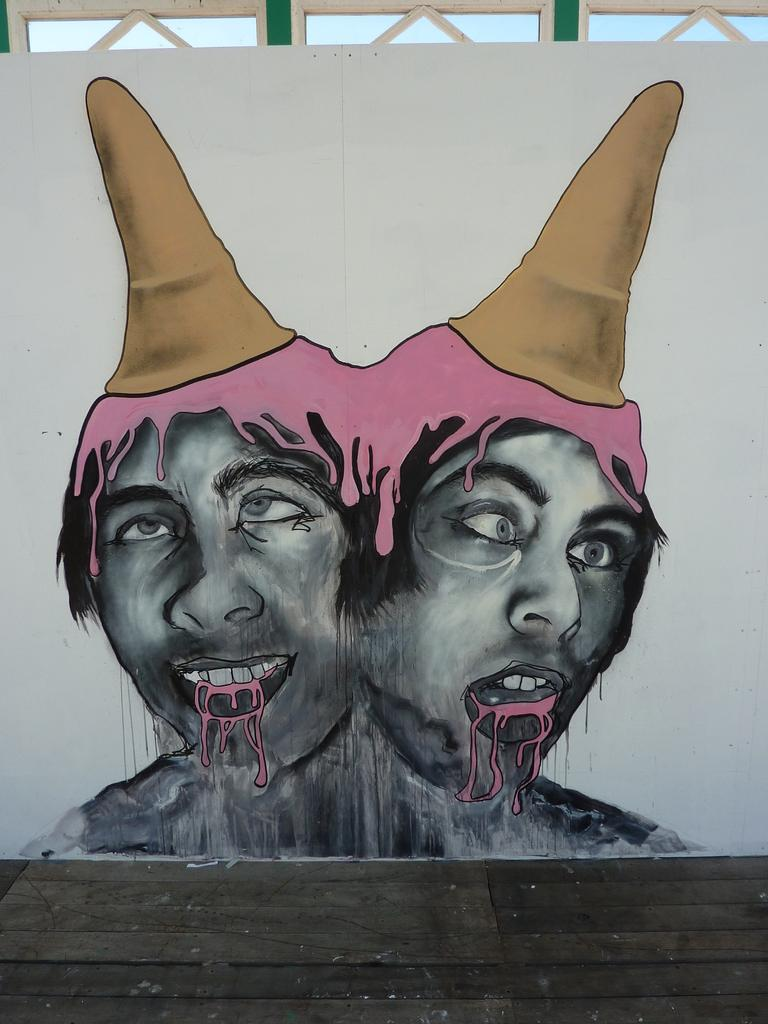What is on the wall in the image? There are paintings on the wall in the image. Who do the paintings belong to? The paintings belong to a person. What type of flooring is visible at the bottom of the image? There is a wooden floor at the bottom of the image. What is visible at the top of the image? The sky is visible at the top of the image. How many dimes can be seen on the wooden floor in the image? There are no dimes visible on the wooden floor in the image. Is there a boy present in the image? There is no mention of a boy in the provided facts, so we cannot determine if a boy is present in the image. 